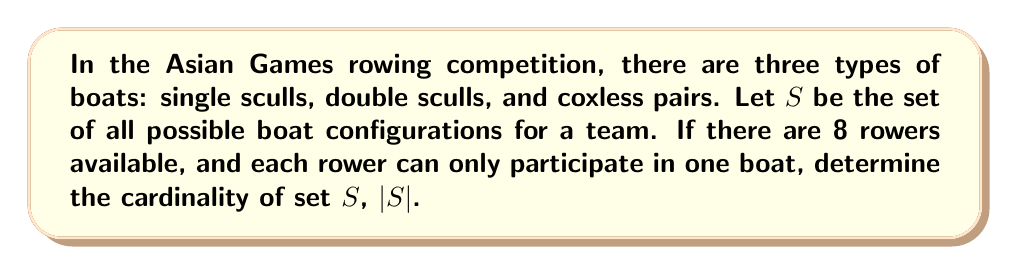Solve this math problem. Let's approach this step-by-step:

1) First, we need to understand the boat types:
   - Single sculls: 1 rower
   - Double sculls: 2 rowers
   - Coxless pairs: 2 rowers

2) Now, let's consider the possible combinations:

   a) All single sculls: $\binom{8}{1} + \binom{7}{1} + \binom{6}{1} + \binom{5}{1} + \binom{4}{1} + \binom{3}{1} + \binom{2}{1} + \binom{1}{1} = 36$

   b) One double scull and the rest single sculls:
      $\binom{8}{2} \cdot \binom{6}{1} \cdot \binom{5}{1} \cdot \binom{4}{1} \cdot \binom{3}{1} \cdot \binom{2}{1} \cdot \binom{1}{1} = 28 \cdot 6! = 20160$

   c) One coxless pair and the rest single sculls:
      $\binom{8}{2} \cdot \binom{6}{1} \cdot \binom{5}{1} \cdot \binom{4}{1} \cdot \binom{3}{1} \cdot \binom{2}{1} \cdot \binom{1}{1} = 28 \cdot 6! = 20160$

   d) Two double sculls and the rest single sculls:
      $\binom{8}{2} \cdot \binom{6}{2} \cdot \binom{4}{1} \cdot \binom{3}{1} \cdot \binom{2}{1} \cdot \binom{1}{1} = 28 \cdot 15 \cdot 4! = 10080$

   e) Two coxless pairs and the rest single sculls:
      $\binom{8}{2} \cdot \binom{6}{2} \cdot \binom{4}{1} \cdot \binom{3}{1} \cdot \binom{2}{1} \cdot \binom{1}{1} = 28 \cdot 15 \cdot 4! = 10080$

   f) One double scull, one coxless pair, and the rest single sculls:
      $\binom{8}{2} \cdot \binom{6}{2} \cdot \binom{4}{1} \cdot \binom{3}{1} \cdot \binom{2}{1} \cdot \binom{1}{1} = 28 \cdot 15 \cdot 4! = 10080$

   g) Two double sculls and two single sculls:
      $\binom{8}{2} \cdot \binom{6}{2} \cdot \binom{4}{1} \cdot \binom{3}{1} = 28 \cdot 15 \cdot 12 = 5040$

   h) Two coxless pairs and two single sculls:
      $\binom{8}{2} \cdot \binom{6}{2} \cdot \binom{4}{1} \cdot \binom{3}{1} = 28 \cdot 15 \cdot 12 = 5040$

   i) One double scull, one coxless pair, and two single sculls:
      $\binom{8}{2} \cdot \binom{6}{2} \cdot \binom{4}{1} \cdot \binom{3}{1} = 28 \cdot 15 \cdot 12 = 5040$

   j) Four double sculls:
      $\binom{8}{2} \cdot \binom{6}{2} \cdot \binom{4}{2} \cdot \binom{2}{2} = 28 \cdot 15 \cdot 6 \cdot 1 = 2520$

   k) Four coxless pairs:
      $\binom{8}{2} \cdot \binom{6}{2} \cdot \binom{4}{2} \cdot \binom{2}{2} = 28 \cdot 15 \cdot 6 \cdot 1 = 2520$

   l) Two double sculls and two coxless pairs:
      $\binom{8}{2} \cdot \binom{6}{2} \cdot \binom{4}{2} \cdot \binom{2}{2} = 28 \cdot 15 \cdot 6 \cdot 1 = 2520$

3) The cardinality of set $S$ is the sum of all these possibilities:

   $|S| = 36 + 20160 + 20160 + 10080 + 10080 + 10080 + 5040 + 5040 + 5040 + 2520 + 2520 + 2520 = 93276$
Answer: The cardinality of set $S$, $|S| = 93276$. 